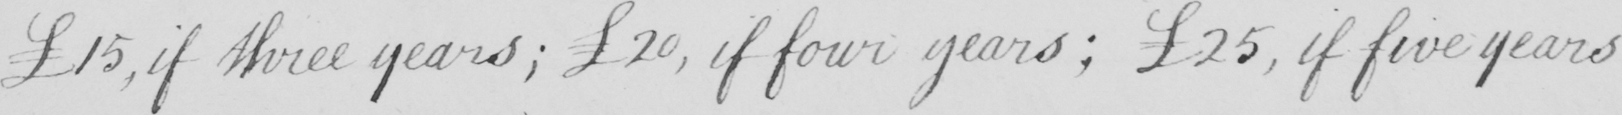What text is written in this handwritten line? £15 , if three years ; 20 , if four years ; £25 , if five years 